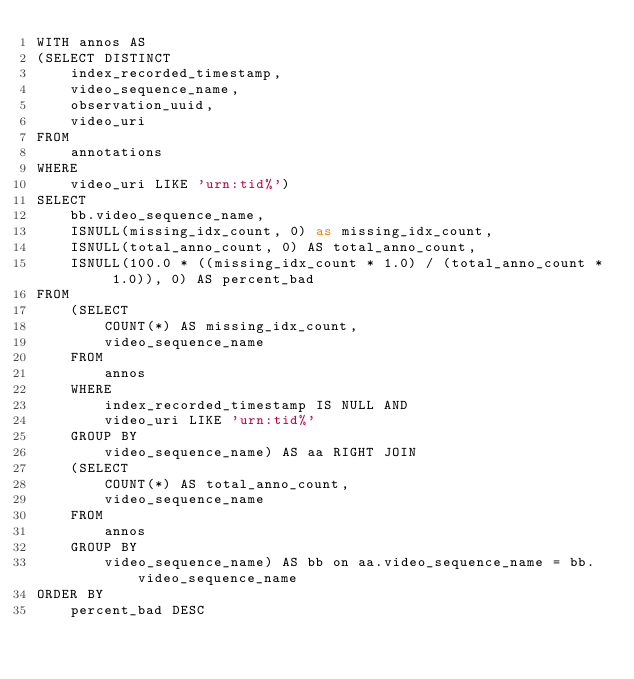Convert code to text. <code><loc_0><loc_0><loc_500><loc_500><_SQL_>WITH annos AS 
(SELECT DISTINCT
    index_recorded_timestamp,
    video_sequence_name,
    observation_uuid,
    video_uri
FROM
    annotations
WHERE 
    video_uri LIKE 'urn:tid%')
SELECT
    bb.video_sequence_name,
    ISNULL(missing_idx_count, 0) as missing_idx_count,
    ISNULL(total_anno_count, 0) AS total_anno_count,
    ISNULL(100.0 * ((missing_idx_count * 1.0) / (total_anno_count * 1.0)), 0) AS percent_bad
FROM
    (SELECT
        COUNT(*) AS missing_idx_count,
        video_sequence_name
    FROM
        annos
    WHERE
        index_recorded_timestamp IS NULL AND
        video_uri LIKE 'urn:tid%'
    GROUP BY
        video_sequence_name) AS aa RIGHT JOIN
    (SELECT
        COUNT(*) AS total_anno_count,
        video_sequence_name
    FROM 
        annos
    GROUP BY
        video_sequence_name) AS bb on aa.video_sequence_name = bb.video_sequence_name
ORDER BY
    percent_bad DESC



    
</code> 